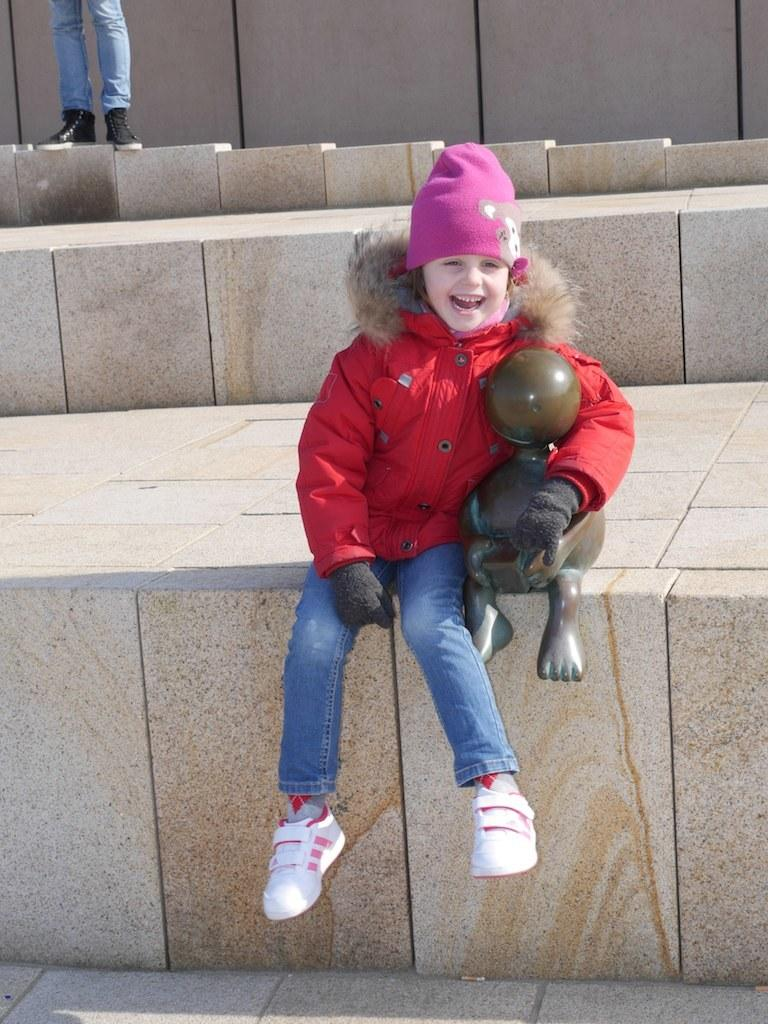Who is the main subject in the picture? There is a girl in the picture. What is the girl doing in the picture? The girl is sitting beside a statue and laughing. Is there anyone else in the picture besides the girl? Yes, there is a person standing behind the girl. What type of error can be seen in the picture? There is no error present in the image. How many planes are visible in the picture? There are no planes visible in the picture. 